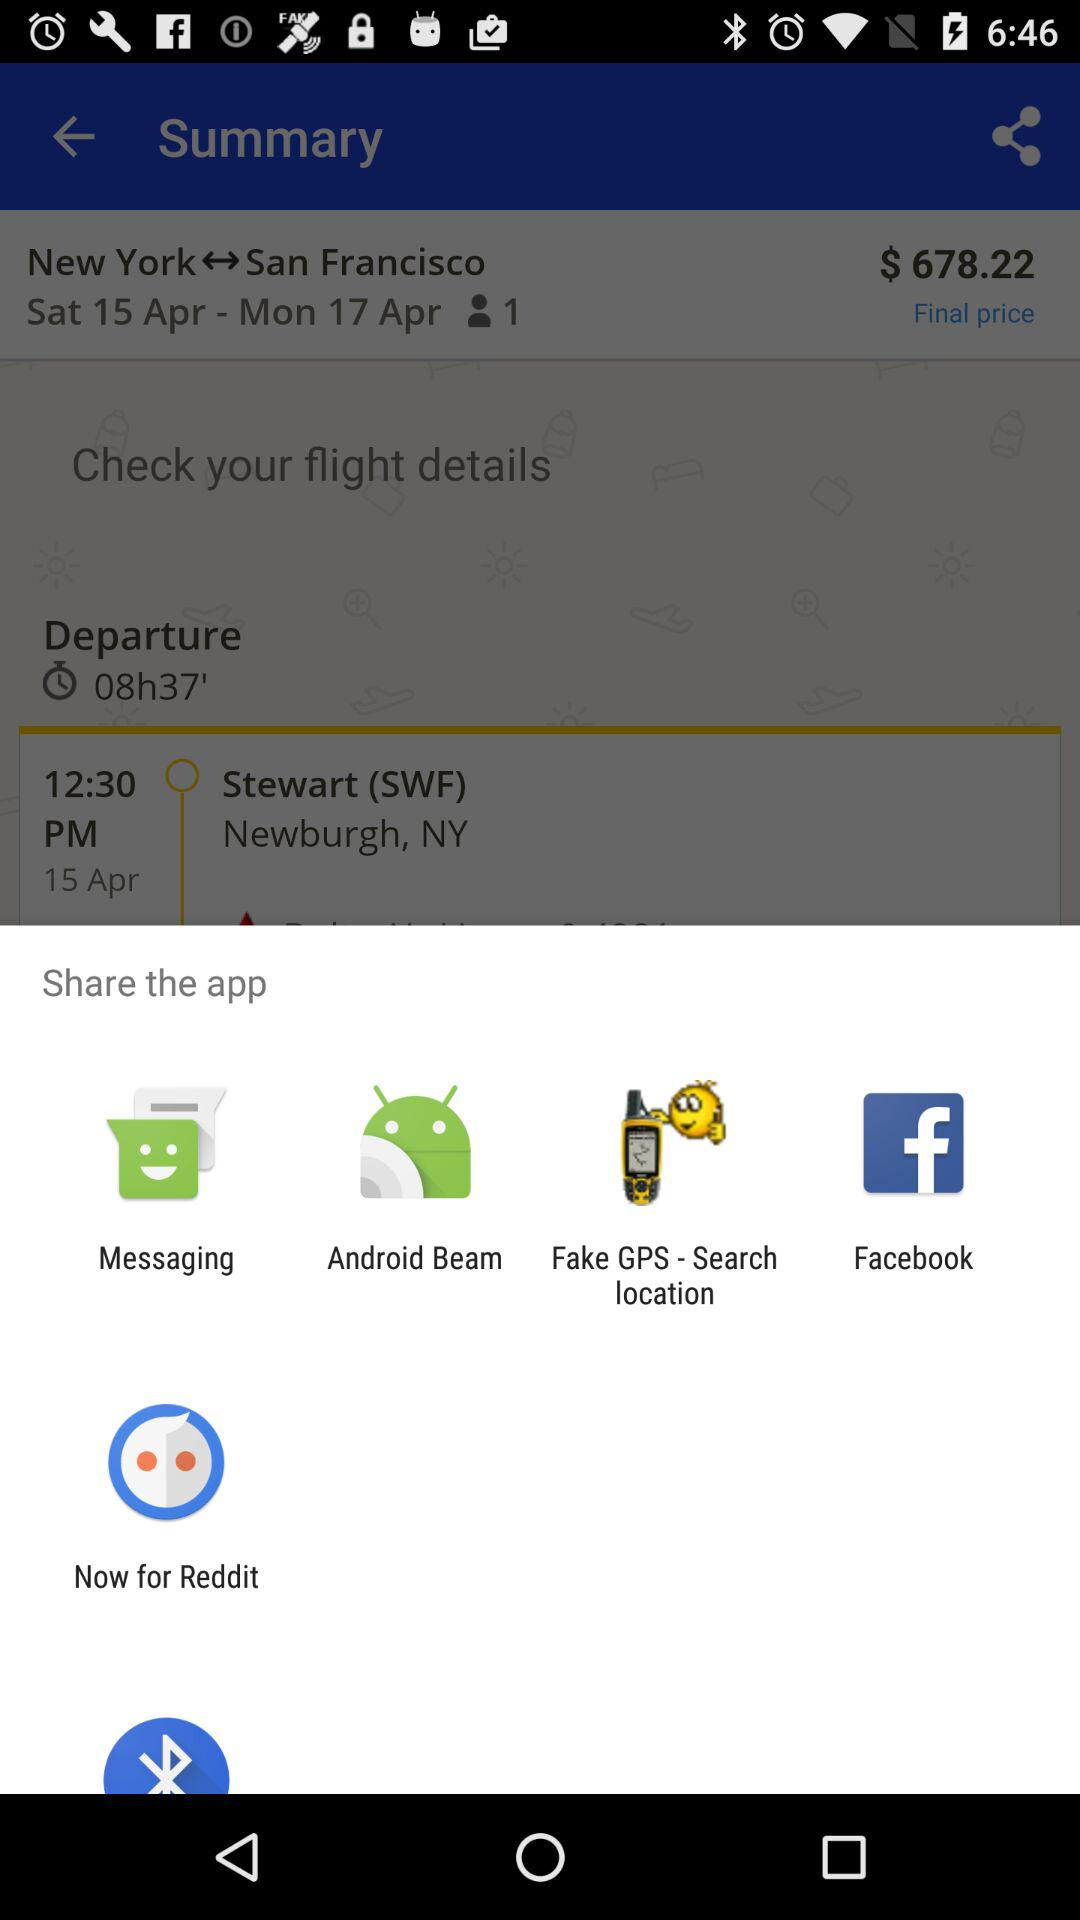What are the different mediums to share the app? The different mediums are "Messaging", "Android Beam", "Fake GPS - Search location", "Facebook" and "Now for Reddit". 